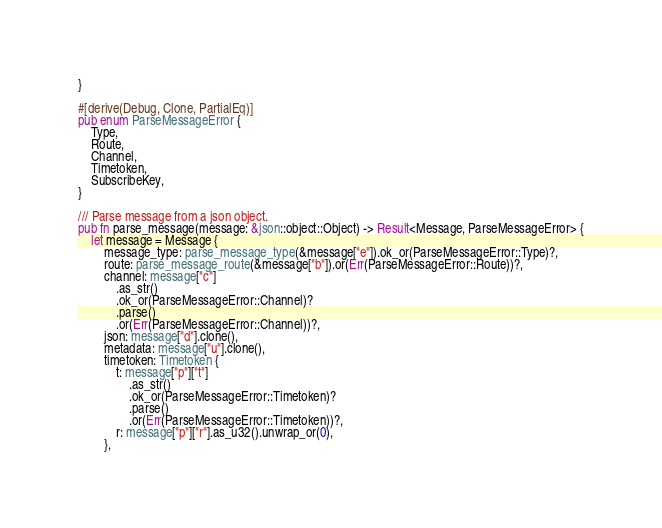Convert code to text. <code><loc_0><loc_0><loc_500><loc_500><_Rust_>}

#[derive(Debug, Clone, PartialEq)]
pub enum ParseMessageError {
    Type,
    Route,
    Channel,
    Timetoken,
    SubscribeKey,
}

/// Parse message from a json object.
pub fn parse_message(message: &json::object::Object) -> Result<Message, ParseMessageError> {
    let message = Message {
        message_type: parse_message_type(&message["e"]).ok_or(ParseMessageError::Type)?,
        route: parse_message_route(&message["b"]).or(Err(ParseMessageError::Route))?,
        channel: message["c"]
            .as_str()
            .ok_or(ParseMessageError::Channel)?
            .parse()
            .or(Err(ParseMessageError::Channel))?,
        json: message["d"].clone(),
        metadata: message["u"].clone(),
        timetoken: Timetoken {
            t: message["p"]["t"]
                .as_str()
                .ok_or(ParseMessageError::Timetoken)?
                .parse()
                .or(Err(ParseMessageError::Timetoken))?,
            r: message["p"]["r"].as_u32().unwrap_or(0),
        },</code> 